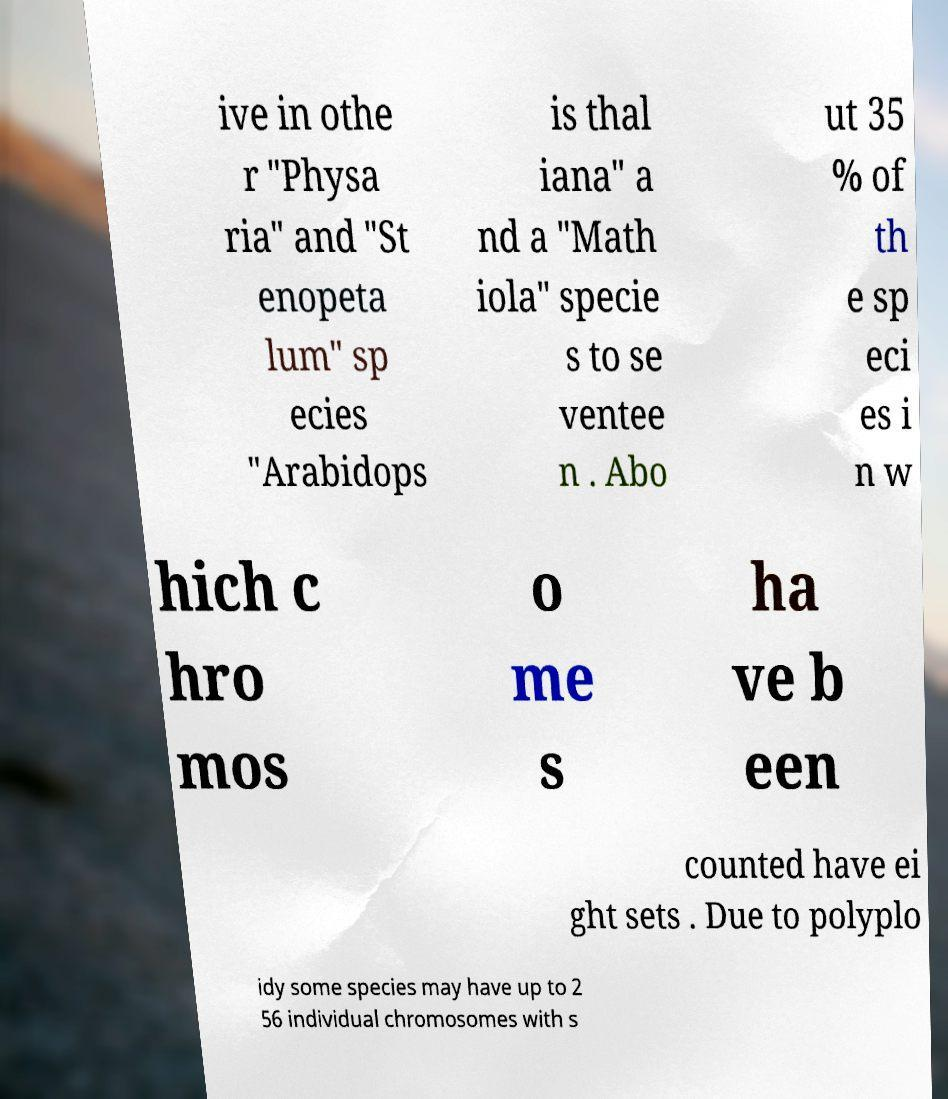There's text embedded in this image that I need extracted. Can you transcribe it verbatim? ive in othe r "Physa ria" and "St enopeta lum" sp ecies "Arabidops is thal iana" a nd a "Math iola" specie s to se ventee n . Abo ut 35 % of th e sp eci es i n w hich c hro mos o me s ha ve b een counted have ei ght sets . Due to polyplo idy some species may have up to 2 56 individual chromosomes with s 